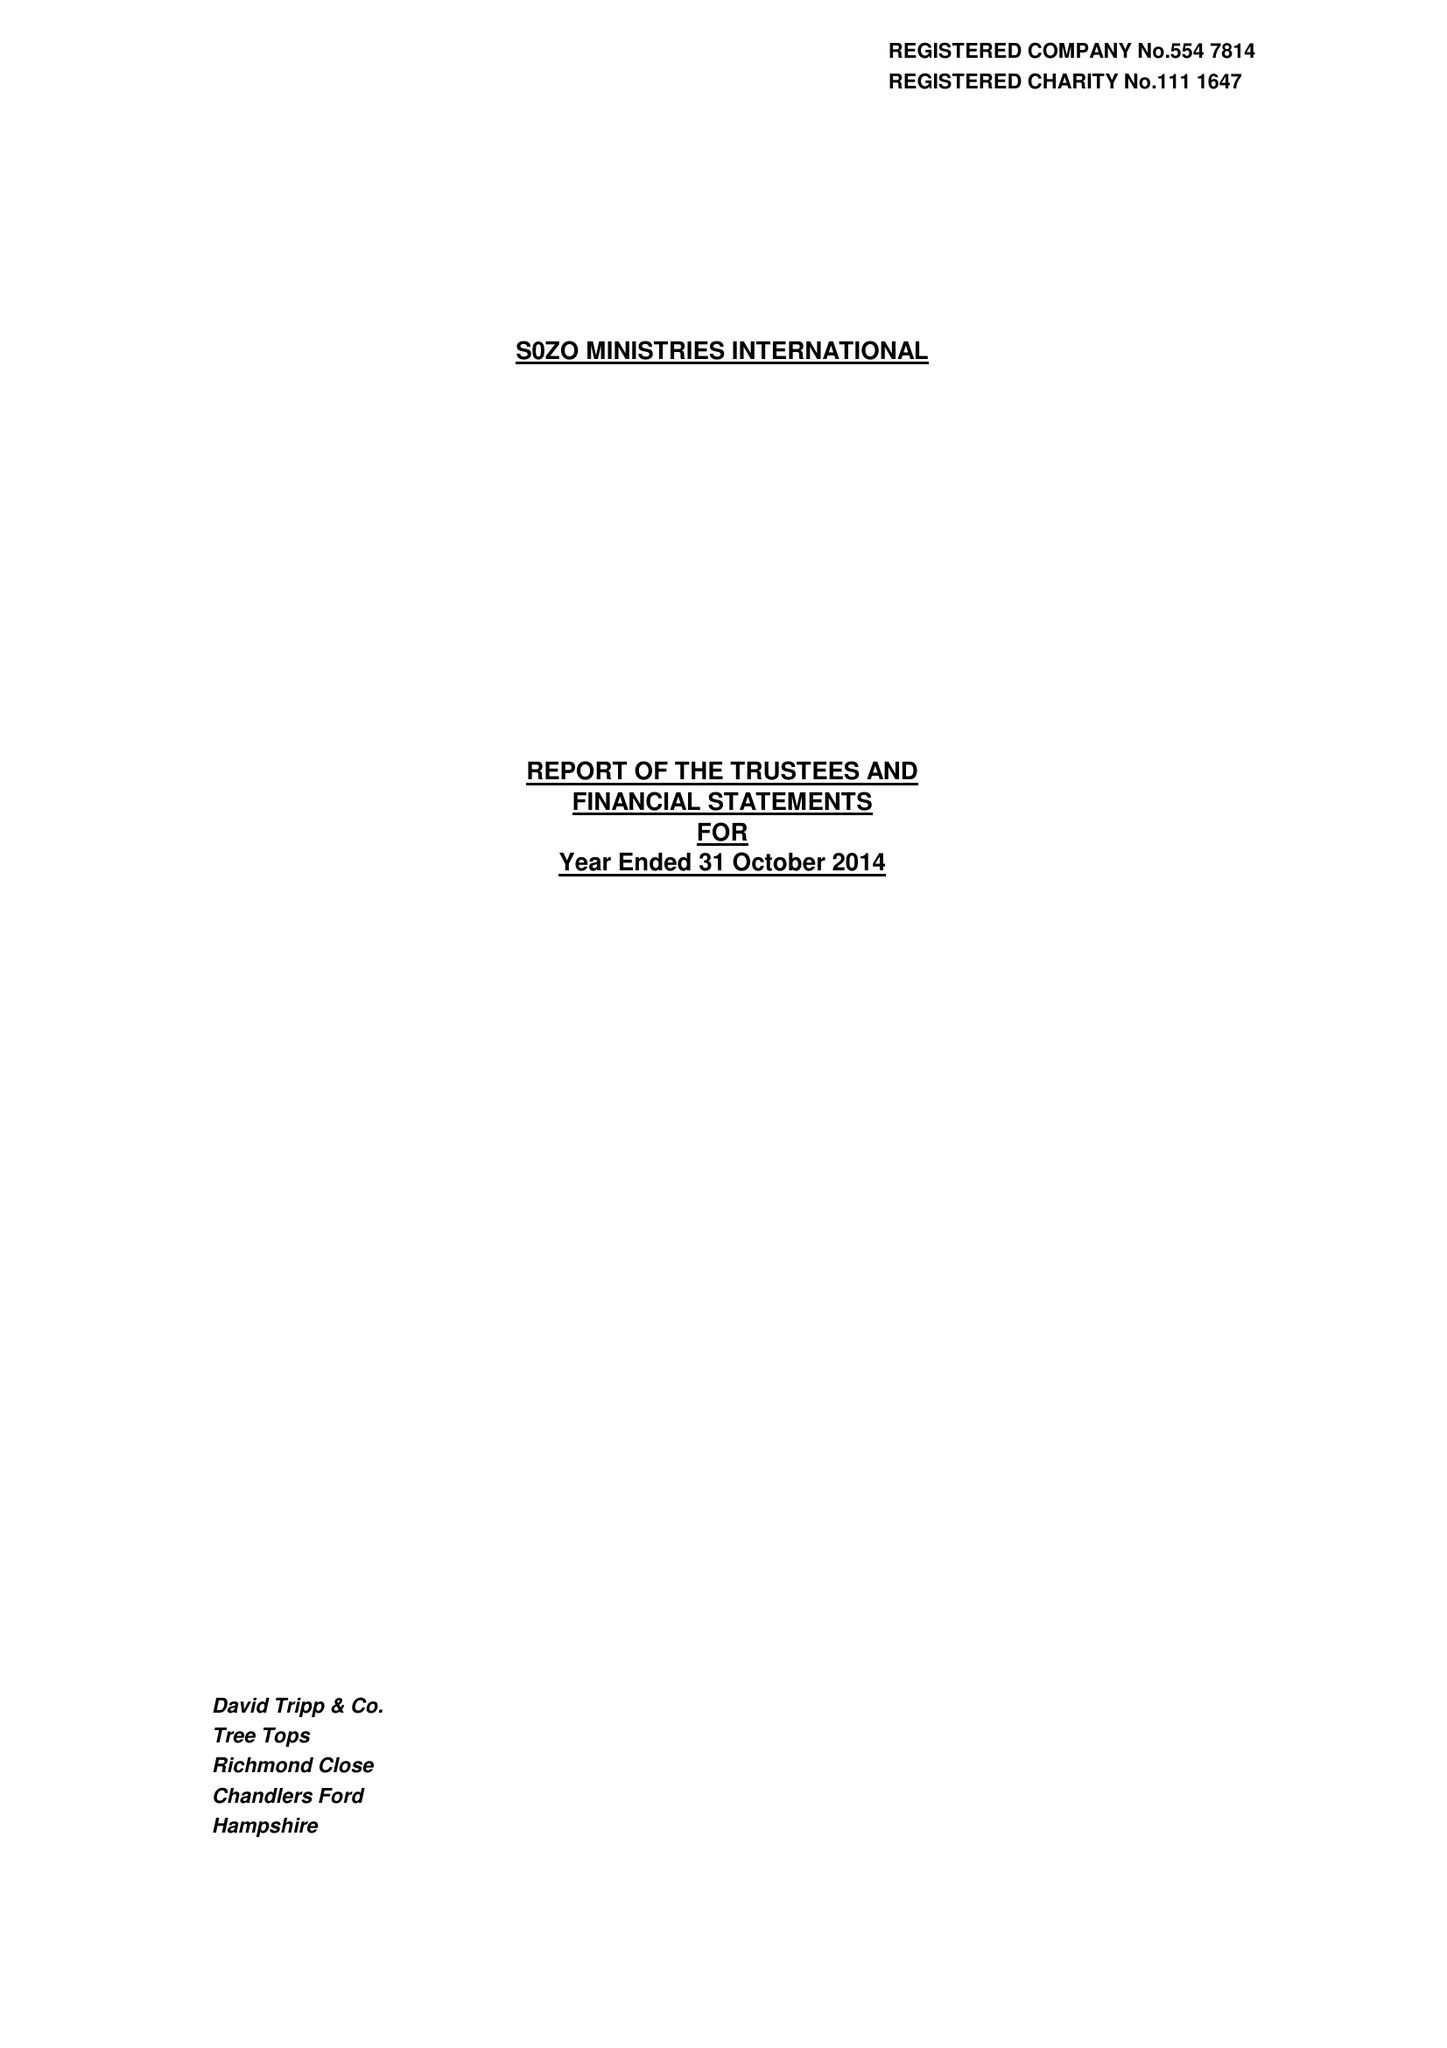What is the value for the address__post_town?
Answer the question using a single word or phrase. ROMSEY 